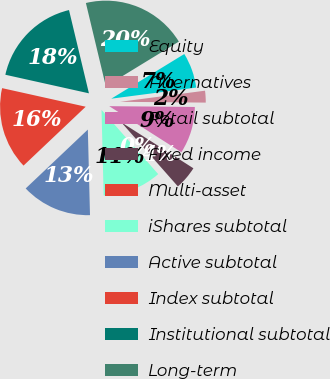<chart> <loc_0><loc_0><loc_500><loc_500><pie_chart><fcel>Equity<fcel>Alternatives<fcel>Retail subtotal<fcel>Fixed income<fcel>Multi-asset<fcel>iShares subtotal<fcel>Active subtotal<fcel>Index subtotal<fcel>Institutional subtotal<fcel>Long-term<nl><fcel>6.67%<fcel>2.22%<fcel>8.89%<fcel>4.45%<fcel>0.0%<fcel>11.11%<fcel>13.33%<fcel>15.55%<fcel>17.78%<fcel>20.0%<nl></chart> 